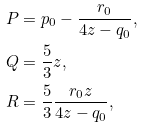Convert formula to latex. <formula><loc_0><loc_0><loc_500><loc_500>P & = p _ { 0 } - \frac { r _ { 0 } } { 4 z - q _ { 0 } } , \\ Q & = \frac { 5 } { 3 } z , \\ R & = \frac { 5 } { 3 } \frac { r _ { 0 } z } { 4 z - q _ { 0 } } ,</formula> 